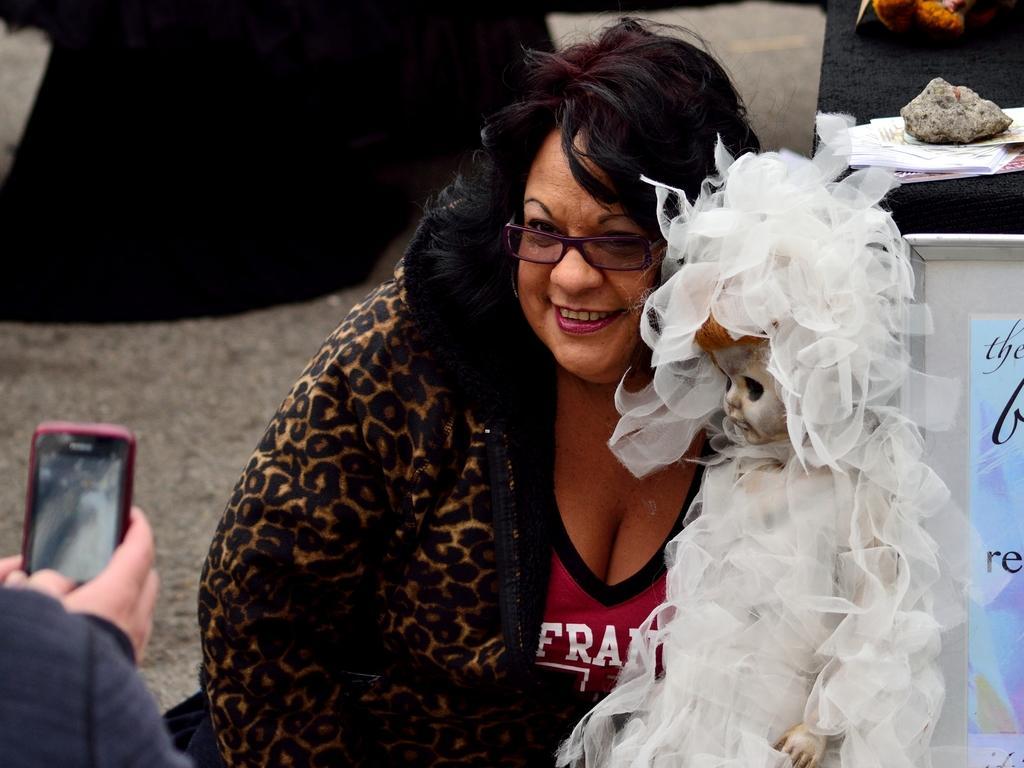Could you give a brief overview of what you see in this image? In the center of the image we can see a lady is sitting and wearing coat and spectacle and holding a doll. In the bottom left corner we can see a person is holding a mobile. In the background of the image we can see some persons. On the right side of the image we can see a table. On the table we can see the papers and stone. In the background of the image we can see the ground. 